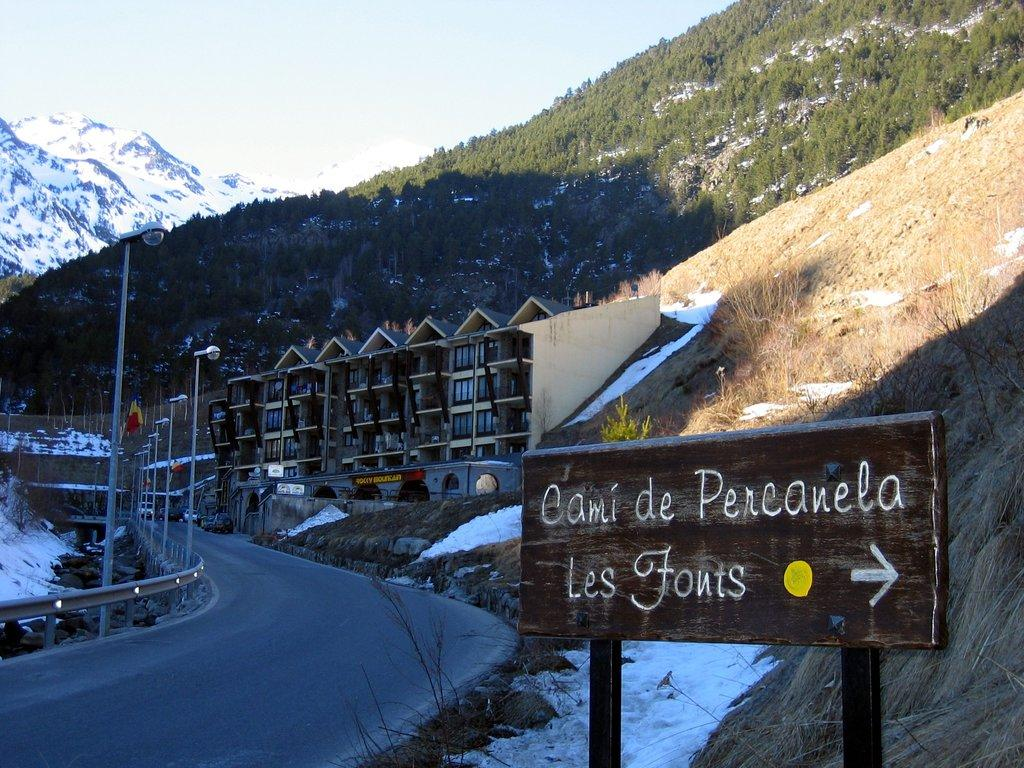What is the main object in the image? There is a sign board in the image. What other structures can be seen in the image? There are street lamps, buildings, and trees in the image. What type of natural feature is present in the image? There are hills in the image. What is the weather condition in the image? There is snow visible in the image, indicating a cold or wintery condition. What is visible at the top of the image? The sky is visible at the top of the image. What type of badge is pinned to the tree in the image? There is no badge present in the image; it features a sign board, street lamps, buildings, hills, trees, snow, and a visible sky. What type of club is being used by the person in the image? There is no person or club present in the image. 